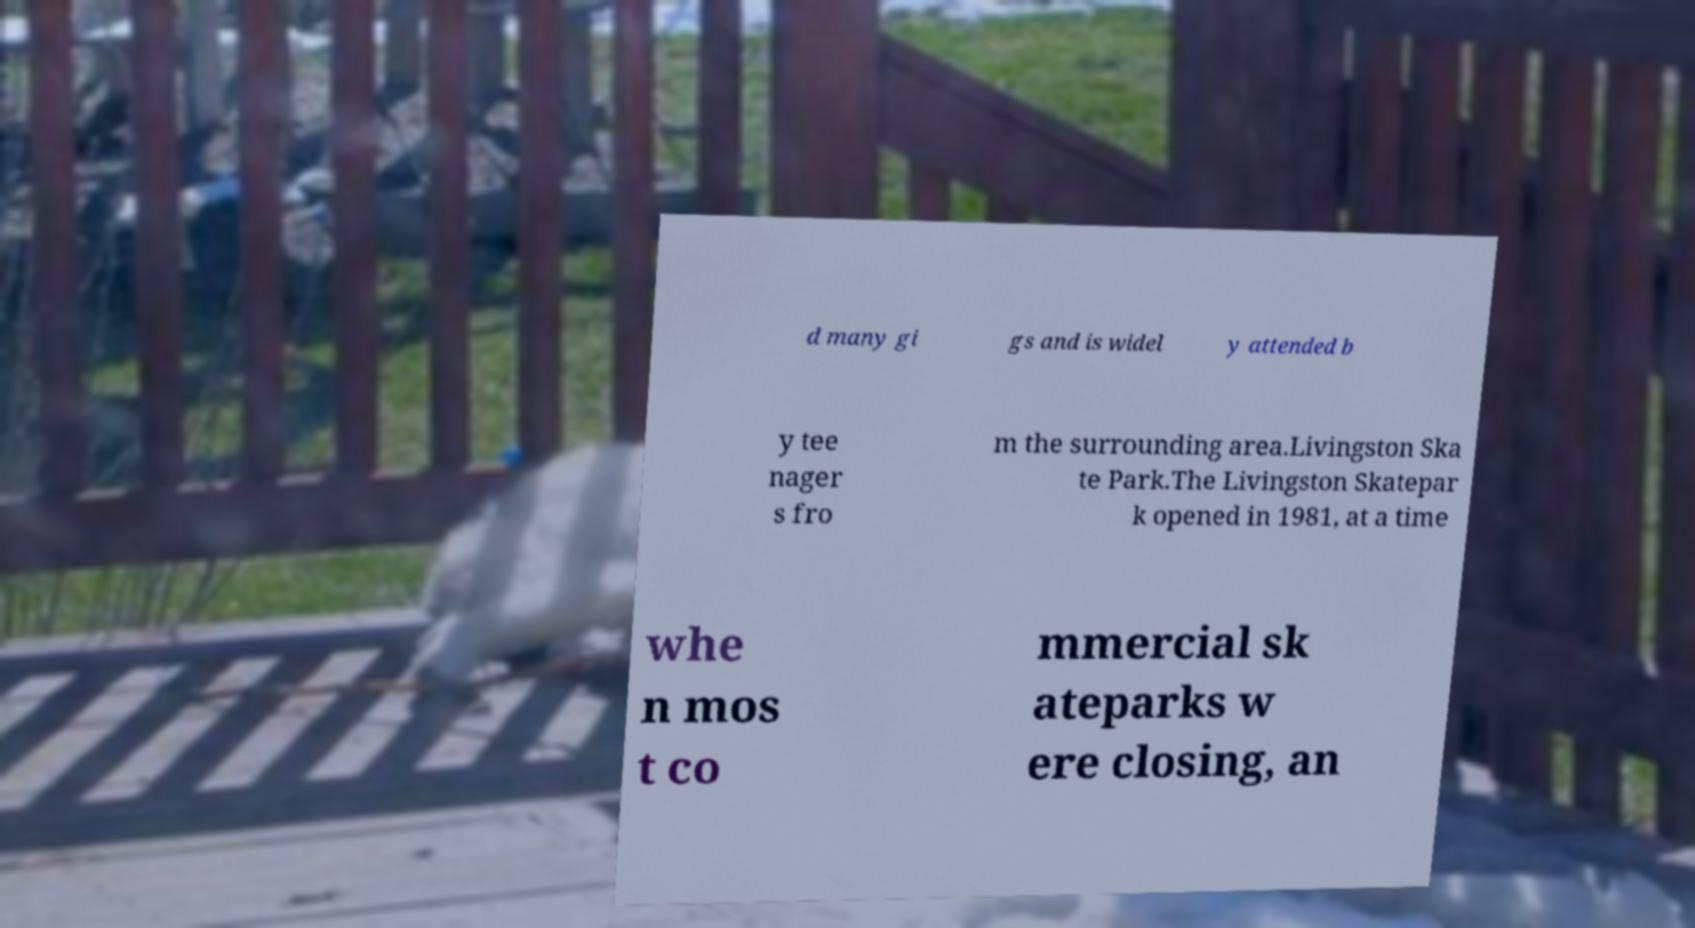Can you accurately transcribe the text from the provided image for me? d many gi gs and is widel y attended b y tee nager s fro m the surrounding area.Livingston Ska te Park.The Livingston Skatepar k opened in 1981, at a time whe n mos t co mmercial sk ateparks w ere closing, an 